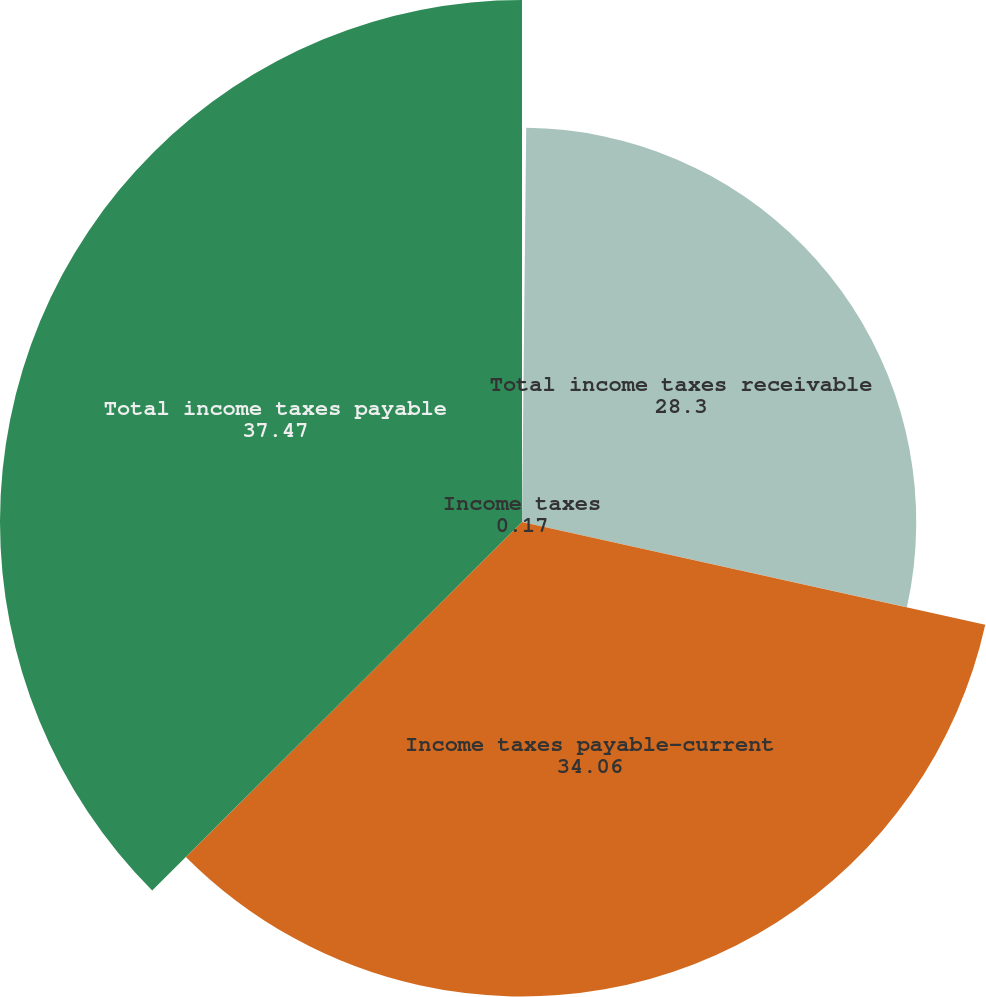<chart> <loc_0><loc_0><loc_500><loc_500><pie_chart><fcel>Income taxes<fcel>Total income taxes receivable<fcel>Income taxes payable-current<fcel>Total income taxes payable<nl><fcel>0.17%<fcel>28.3%<fcel>34.06%<fcel>37.47%<nl></chart> 